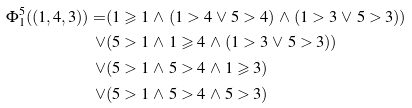<formula> <loc_0><loc_0><loc_500><loc_500>\Phi ^ { 5 } _ { 1 } ( ( 1 , 4 , 3 ) ) = & ( 1 \geqslant 1 \, \land \, ( 1 > 4 \, \lor \, 5 > 4 ) \, \land \, ( 1 > 3 \, \lor \, 5 > 3 ) ) \\ \lor & ( 5 > 1 \, \land \, 1 \geqslant 4 \, \land \, ( 1 > 3 \, \lor \, 5 > 3 ) ) \\ \lor & ( 5 > 1 \, \land \, 5 > 4 \, \land \, 1 \geqslant 3 ) \\ \lor & ( 5 > 1 \, \land \, 5 > 4 \, \land \, 5 > 3 )</formula> 